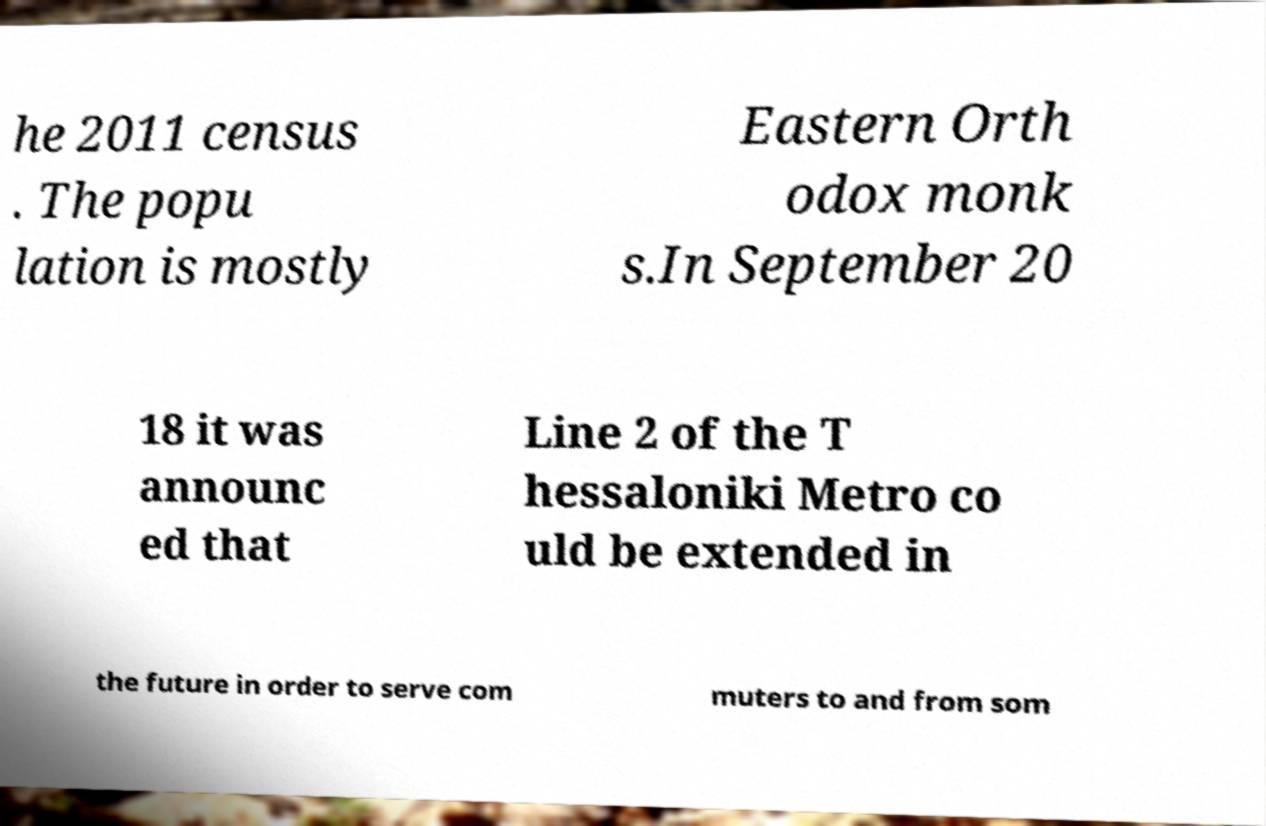Please identify and transcribe the text found in this image. he 2011 census . The popu lation is mostly Eastern Orth odox monk s.In September 20 18 it was announc ed that Line 2 of the T hessaloniki Metro co uld be extended in the future in order to serve com muters to and from som 